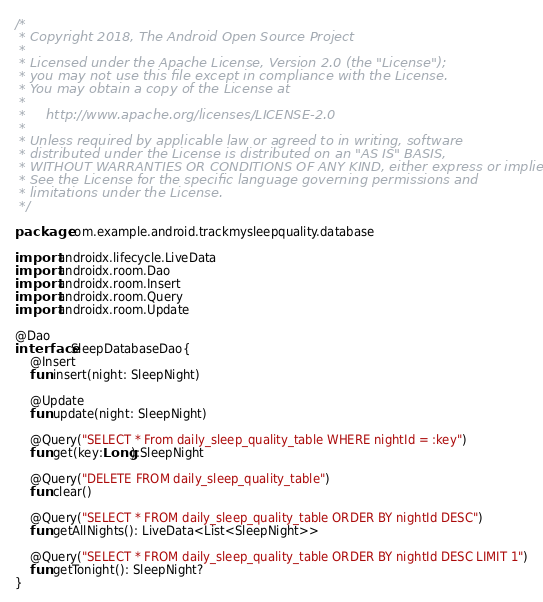<code> <loc_0><loc_0><loc_500><loc_500><_Kotlin_>/*
 * Copyright 2018, The Android Open Source Project
 *
 * Licensed under the Apache License, Version 2.0 (the "License");
 * you may not use this file except in compliance with the License.
 * You may obtain a copy of the License at
 *
 *     http://www.apache.org/licenses/LICENSE-2.0
 *
 * Unless required by applicable law or agreed to in writing, software
 * distributed under the License is distributed on an "AS IS" BASIS,
 * WITHOUT WARRANTIES OR CONDITIONS OF ANY KIND, either express or implied.
 * See the License for the specific language governing permissions and
 * limitations under the License.
 */

package com.example.android.trackmysleepquality.database

import androidx.lifecycle.LiveData
import androidx.room.Dao
import androidx.room.Insert
import androidx.room.Query
import androidx.room.Update

@Dao
interface SleepDatabaseDao{
    @Insert
    fun insert(night: SleepNight)

    @Update
    fun update(night: SleepNight)

    @Query("SELECT * From daily_sleep_quality_table WHERE nightId = :key")
    fun get(key:Long):SleepNight

    @Query("DELETE FROM daily_sleep_quality_table")
    fun clear()

    @Query("SELECT * FROM daily_sleep_quality_table ORDER BY nightId DESC")
    fun getAllNights(): LiveData<List<SleepNight>>

    @Query("SELECT * FROM daily_sleep_quality_table ORDER BY nightId DESC LIMIT 1")
    fun getTonight(): SleepNight?
}
</code> 